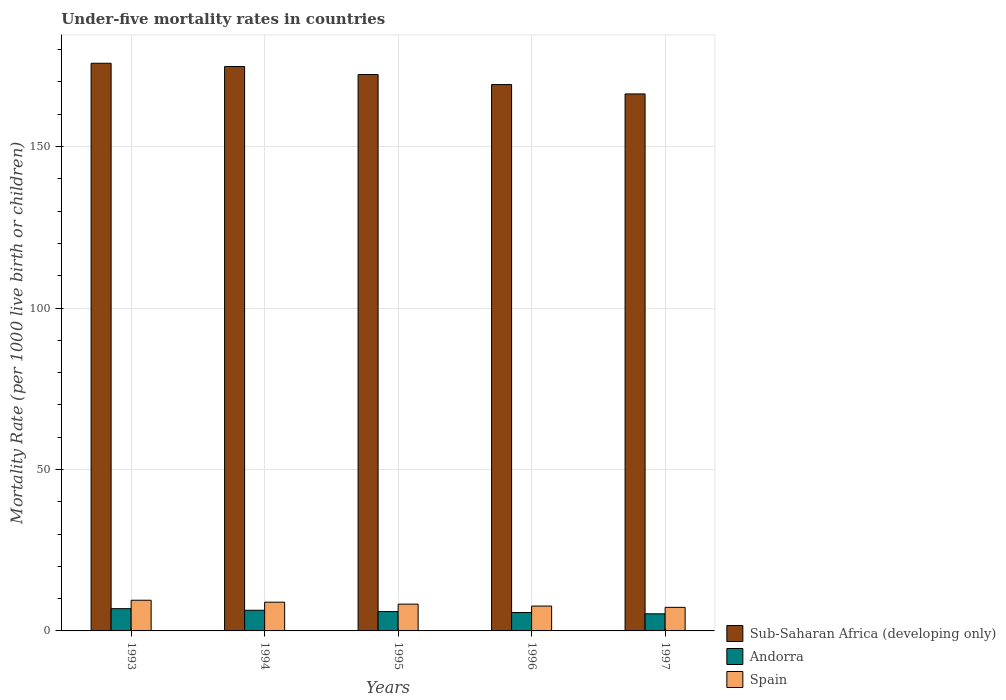How many bars are there on the 3rd tick from the left?
Offer a terse response. 3. What is the label of the 5th group of bars from the left?
Your answer should be very brief. 1997. In how many cases, is the number of bars for a given year not equal to the number of legend labels?
Keep it short and to the point. 0. Across all years, what is the maximum under-five mortality rate in Andorra?
Offer a very short reply. 6.9. In which year was the under-five mortality rate in Sub-Saharan Africa (developing only) minimum?
Offer a terse response. 1997. What is the total under-five mortality rate in Sub-Saharan Africa (developing only) in the graph?
Provide a short and direct response. 858.4. What is the difference between the under-five mortality rate in Spain in 1994 and that in 1995?
Your answer should be very brief. 0.6. What is the difference between the under-five mortality rate in Andorra in 1993 and the under-five mortality rate in Sub-Saharan Africa (developing only) in 1997?
Provide a succinct answer. -159.4. What is the average under-five mortality rate in Sub-Saharan Africa (developing only) per year?
Offer a very short reply. 171.68. What is the ratio of the under-five mortality rate in Sub-Saharan Africa (developing only) in 1995 to that in 1996?
Offer a terse response. 1.02. Is the difference between the under-five mortality rate in Andorra in 1993 and 1997 greater than the difference between the under-five mortality rate in Spain in 1993 and 1997?
Keep it short and to the point. No. What is the difference between the highest and the second highest under-five mortality rate in Sub-Saharan Africa (developing only)?
Give a very brief answer. 1. In how many years, is the under-five mortality rate in Sub-Saharan Africa (developing only) greater than the average under-five mortality rate in Sub-Saharan Africa (developing only) taken over all years?
Your response must be concise. 3. Is it the case that in every year, the sum of the under-five mortality rate in Sub-Saharan Africa (developing only) and under-five mortality rate in Spain is greater than the under-five mortality rate in Andorra?
Provide a succinct answer. Yes. How many bars are there?
Give a very brief answer. 15. Where does the legend appear in the graph?
Provide a succinct answer. Bottom right. How are the legend labels stacked?
Your response must be concise. Vertical. What is the title of the graph?
Your answer should be very brief. Under-five mortality rates in countries. Does "Cabo Verde" appear as one of the legend labels in the graph?
Your answer should be compact. No. What is the label or title of the Y-axis?
Provide a short and direct response. Mortality Rate (per 1000 live birth or children). What is the Mortality Rate (per 1000 live birth or children) in Sub-Saharan Africa (developing only) in 1993?
Ensure brevity in your answer.  175.8. What is the Mortality Rate (per 1000 live birth or children) of Andorra in 1993?
Provide a succinct answer. 6.9. What is the Mortality Rate (per 1000 live birth or children) in Sub-Saharan Africa (developing only) in 1994?
Offer a terse response. 174.8. What is the Mortality Rate (per 1000 live birth or children) of Spain in 1994?
Offer a terse response. 8.9. What is the Mortality Rate (per 1000 live birth or children) of Sub-Saharan Africa (developing only) in 1995?
Your answer should be compact. 172.3. What is the Mortality Rate (per 1000 live birth or children) in Spain in 1995?
Make the answer very short. 8.3. What is the Mortality Rate (per 1000 live birth or children) in Sub-Saharan Africa (developing only) in 1996?
Offer a terse response. 169.2. What is the Mortality Rate (per 1000 live birth or children) of Sub-Saharan Africa (developing only) in 1997?
Offer a very short reply. 166.3. What is the Mortality Rate (per 1000 live birth or children) in Spain in 1997?
Make the answer very short. 7.3. Across all years, what is the maximum Mortality Rate (per 1000 live birth or children) in Sub-Saharan Africa (developing only)?
Your answer should be compact. 175.8. Across all years, what is the minimum Mortality Rate (per 1000 live birth or children) of Sub-Saharan Africa (developing only)?
Offer a terse response. 166.3. Across all years, what is the minimum Mortality Rate (per 1000 live birth or children) of Spain?
Ensure brevity in your answer.  7.3. What is the total Mortality Rate (per 1000 live birth or children) of Sub-Saharan Africa (developing only) in the graph?
Make the answer very short. 858.4. What is the total Mortality Rate (per 1000 live birth or children) of Andorra in the graph?
Ensure brevity in your answer.  30.3. What is the total Mortality Rate (per 1000 live birth or children) in Spain in the graph?
Give a very brief answer. 41.7. What is the difference between the Mortality Rate (per 1000 live birth or children) in Andorra in 1993 and that in 1994?
Offer a terse response. 0.5. What is the difference between the Mortality Rate (per 1000 live birth or children) of Spain in 1993 and that in 1994?
Ensure brevity in your answer.  0.6. What is the difference between the Mortality Rate (per 1000 live birth or children) in Sub-Saharan Africa (developing only) in 1993 and that in 1995?
Give a very brief answer. 3.5. What is the difference between the Mortality Rate (per 1000 live birth or children) in Andorra in 1993 and that in 1995?
Make the answer very short. 0.9. What is the difference between the Mortality Rate (per 1000 live birth or children) of Spain in 1993 and that in 1995?
Your response must be concise. 1.2. What is the difference between the Mortality Rate (per 1000 live birth or children) in Sub-Saharan Africa (developing only) in 1993 and that in 1996?
Make the answer very short. 6.6. What is the difference between the Mortality Rate (per 1000 live birth or children) in Spain in 1993 and that in 1996?
Your response must be concise. 1.8. What is the difference between the Mortality Rate (per 1000 live birth or children) of Spain in 1993 and that in 1997?
Make the answer very short. 2.2. What is the difference between the Mortality Rate (per 1000 live birth or children) of Sub-Saharan Africa (developing only) in 1994 and that in 1995?
Make the answer very short. 2.5. What is the difference between the Mortality Rate (per 1000 live birth or children) of Spain in 1994 and that in 1995?
Make the answer very short. 0.6. What is the difference between the Mortality Rate (per 1000 live birth or children) of Andorra in 1994 and that in 1997?
Your response must be concise. 1.1. What is the difference between the Mortality Rate (per 1000 live birth or children) of Sub-Saharan Africa (developing only) in 1995 and that in 1996?
Offer a very short reply. 3.1. What is the difference between the Mortality Rate (per 1000 live birth or children) in Andorra in 1995 and that in 1996?
Offer a terse response. 0.3. What is the difference between the Mortality Rate (per 1000 live birth or children) of Andorra in 1995 and that in 1997?
Provide a short and direct response. 0.7. What is the difference between the Mortality Rate (per 1000 live birth or children) in Sub-Saharan Africa (developing only) in 1996 and that in 1997?
Keep it short and to the point. 2.9. What is the difference between the Mortality Rate (per 1000 live birth or children) of Andorra in 1996 and that in 1997?
Your answer should be very brief. 0.4. What is the difference between the Mortality Rate (per 1000 live birth or children) in Spain in 1996 and that in 1997?
Your answer should be compact. 0.4. What is the difference between the Mortality Rate (per 1000 live birth or children) in Sub-Saharan Africa (developing only) in 1993 and the Mortality Rate (per 1000 live birth or children) in Andorra in 1994?
Keep it short and to the point. 169.4. What is the difference between the Mortality Rate (per 1000 live birth or children) of Sub-Saharan Africa (developing only) in 1993 and the Mortality Rate (per 1000 live birth or children) of Spain in 1994?
Provide a succinct answer. 166.9. What is the difference between the Mortality Rate (per 1000 live birth or children) in Andorra in 1993 and the Mortality Rate (per 1000 live birth or children) in Spain in 1994?
Ensure brevity in your answer.  -2. What is the difference between the Mortality Rate (per 1000 live birth or children) in Sub-Saharan Africa (developing only) in 1993 and the Mortality Rate (per 1000 live birth or children) in Andorra in 1995?
Make the answer very short. 169.8. What is the difference between the Mortality Rate (per 1000 live birth or children) of Sub-Saharan Africa (developing only) in 1993 and the Mortality Rate (per 1000 live birth or children) of Spain in 1995?
Offer a very short reply. 167.5. What is the difference between the Mortality Rate (per 1000 live birth or children) in Andorra in 1993 and the Mortality Rate (per 1000 live birth or children) in Spain in 1995?
Offer a very short reply. -1.4. What is the difference between the Mortality Rate (per 1000 live birth or children) in Sub-Saharan Africa (developing only) in 1993 and the Mortality Rate (per 1000 live birth or children) in Andorra in 1996?
Keep it short and to the point. 170.1. What is the difference between the Mortality Rate (per 1000 live birth or children) of Sub-Saharan Africa (developing only) in 1993 and the Mortality Rate (per 1000 live birth or children) of Spain in 1996?
Offer a terse response. 168.1. What is the difference between the Mortality Rate (per 1000 live birth or children) of Sub-Saharan Africa (developing only) in 1993 and the Mortality Rate (per 1000 live birth or children) of Andorra in 1997?
Give a very brief answer. 170.5. What is the difference between the Mortality Rate (per 1000 live birth or children) in Sub-Saharan Africa (developing only) in 1993 and the Mortality Rate (per 1000 live birth or children) in Spain in 1997?
Your answer should be very brief. 168.5. What is the difference between the Mortality Rate (per 1000 live birth or children) in Sub-Saharan Africa (developing only) in 1994 and the Mortality Rate (per 1000 live birth or children) in Andorra in 1995?
Your response must be concise. 168.8. What is the difference between the Mortality Rate (per 1000 live birth or children) in Sub-Saharan Africa (developing only) in 1994 and the Mortality Rate (per 1000 live birth or children) in Spain in 1995?
Ensure brevity in your answer.  166.5. What is the difference between the Mortality Rate (per 1000 live birth or children) in Andorra in 1994 and the Mortality Rate (per 1000 live birth or children) in Spain in 1995?
Make the answer very short. -1.9. What is the difference between the Mortality Rate (per 1000 live birth or children) of Sub-Saharan Africa (developing only) in 1994 and the Mortality Rate (per 1000 live birth or children) of Andorra in 1996?
Give a very brief answer. 169.1. What is the difference between the Mortality Rate (per 1000 live birth or children) of Sub-Saharan Africa (developing only) in 1994 and the Mortality Rate (per 1000 live birth or children) of Spain in 1996?
Make the answer very short. 167.1. What is the difference between the Mortality Rate (per 1000 live birth or children) of Sub-Saharan Africa (developing only) in 1994 and the Mortality Rate (per 1000 live birth or children) of Andorra in 1997?
Provide a succinct answer. 169.5. What is the difference between the Mortality Rate (per 1000 live birth or children) in Sub-Saharan Africa (developing only) in 1994 and the Mortality Rate (per 1000 live birth or children) in Spain in 1997?
Your answer should be compact. 167.5. What is the difference between the Mortality Rate (per 1000 live birth or children) in Sub-Saharan Africa (developing only) in 1995 and the Mortality Rate (per 1000 live birth or children) in Andorra in 1996?
Offer a very short reply. 166.6. What is the difference between the Mortality Rate (per 1000 live birth or children) of Sub-Saharan Africa (developing only) in 1995 and the Mortality Rate (per 1000 live birth or children) of Spain in 1996?
Provide a short and direct response. 164.6. What is the difference between the Mortality Rate (per 1000 live birth or children) of Sub-Saharan Africa (developing only) in 1995 and the Mortality Rate (per 1000 live birth or children) of Andorra in 1997?
Keep it short and to the point. 167. What is the difference between the Mortality Rate (per 1000 live birth or children) of Sub-Saharan Africa (developing only) in 1995 and the Mortality Rate (per 1000 live birth or children) of Spain in 1997?
Make the answer very short. 165. What is the difference between the Mortality Rate (per 1000 live birth or children) in Sub-Saharan Africa (developing only) in 1996 and the Mortality Rate (per 1000 live birth or children) in Andorra in 1997?
Offer a very short reply. 163.9. What is the difference between the Mortality Rate (per 1000 live birth or children) in Sub-Saharan Africa (developing only) in 1996 and the Mortality Rate (per 1000 live birth or children) in Spain in 1997?
Provide a succinct answer. 161.9. What is the average Mortality Rate (per 1000 live birth or children) of Sub-Saharan Africa (developing only) per year?
Provide a short and direct response. 171.68. What is the average Mortality Rate (per 1000 live birth or children) in Andorra per year?
Keep it short and to the point. 6.06. What is the average Mortality Rate (per 1000 live birth or children) of Spain per year?
Offer a very short reply. 8.34. In the year 1993, what is the difference between the Mortality Rate (per 1000 live birth or children) of Sub-Saharan Africa (developing only) and Mortality Rate (per 1000 live birth or children) of Andorra?
Your response must be concise. 168.9. In the year 1993, what is the difference between the Mortality Rate (per 1000 live birth or children) in Sub-Saharan Africa (developing only) and Mortality Rate (per 1000 live birth or children) in Spain?
Offer a very short reply. 166.3. In the year 1994, what is the difference between the Mortality Rate (per 1000 live birth or children) in Sub-Saharan Africa (developing only) and Mortality Rate (per 1000 live birth or children) in Andorra?
Provide a short and direct response. 168.4. In the year 1994, what is the difference between the Mortality Rate (per 1000 live birth or children) of Sub-Saharan Africa (developing only) and Mortality Rate (per 1000 live birth or children) of Spain?
Offer a very short reply. 165.9. In the year 1995, what is the difference between the Mortality Rate (per 1000 live birth or children) in Sub-Saharan Africa (developing only) and Mortality Rate (per 1000 live birth or children) in Andorra?
Your response must be concise. 166.3. In the year 1995, what is the difference between the Mortality Rate (per 1000 live birth or children) of Sub-Saharan Africa (developing only) and Mortality Rate (per 1000 live birth or children) of Spain?
Your answer should be very brief. 164. In the year 1995, what is the difference between the Mortality Rate (per 1000 live birth or children) in Andorra and Mortality Rate (per 1000 live birth or children) in Spain?
Your answer should be compact. -2.3. In the year 1996, what is the difference between the Mortality Rate (per 1000 live birth or children) in Sub-Saharan Africa (developing only) and Mortality Rate (per 1000 live birth or children) in Andorra?
Your answer should be compact. 163.5. In the year 1996, what is the difference between the Mortality Rate (per 1000 live birth or children) of Sub-Saharan Africa (developing only) and Mortality Rate (per 1000 live birth or children) of Spain?
Ensure brevity in your answer.  161.5. In the year 1996, what is the difference between the Mortality Rate (per 1000 live birth or children) in Andorra and Mortality Rate (per 1000 live birth or children) in Spain?
Ensure brevity in your answer.  -2. In the year 1997, what is the difference between the Mortality Rate (per 1000 live birth or children) in Sub-Saharan Africa (developing only) and Mortality Rate (per 1000 live birth or children) in Andorra?
Offer a terse response. 161. In the year 1997, what is the difference between the Mortality Rate (per 1000 live birth or children) in Sub-Saharan Africa (developing only) and Mortality Rate (per 1000 live birth or children) in Spain?
Provide a succinct answer. 159. In the year 1997, what is the difference between the Mortality Rate (per 1000 live birth or children) of Andorra and Mortality Rate (per 1000 live birth or children) of Spain?
Your answer should be compact. -2. What is the ratio of the Mortality Rate (per 1000 live birth or children) of Sub-Saharan Africa (developing only) in 1993 to that in 1994?
Give a very brief answer. 1.01. What is the ratio of the Mortality Rate (per 1000 live birth or children) of Andorra in 1993 to that in 1994?
Offer a terse response. 1.08. What is the ratio of the Mortality Rate (per 1000 live birth or children) of Spain in 1993 to that in 1994?
Offer a terse response. 1.07. What is the ratio of the Mortality Rate (per 1000 live birth or children) in Sub-Saharan Africa (developing only) in 1993 to that in 1995?
Make the answer very short. 1.02. What is the ratio of the Mortality Rate (per 1000 live birth or children) of Andorra in 1993 to that in 1995?
Make the answer very short. 1.15. What is the ratio of the Mortality Rate (per 1000 live birth or children) in Spain in 1993 to that in 1995?
Your answer should be compact. 1.14. What is the ratio of the Mortality Rate (per 1000 live birth or children) of Sub-Saharan Africa (developing only) in 1993 to that in 1996?
Provide a succinct answer. 1.04. What is the ratio of the Mortality Rate (per 1000 live birth or children) of Andorra in 1993 to that in 1996?
Provide a short and direct response. 1.21. What is the ratio of the Mortality Rate (per 1000 live birth or children) in Spain in 1993 to that in 1996?
Your response must be concise. 1.23. What is the ratio of the Mortality Rate (per 1000 live birth or children) of Sub-Saharan Africa (developing only) in 1993 to that in 1997?
Your answer should be very brief. 1.06. What is the ratio of the Mortality Rate (per 1000 live birth or children) of Andorra in 1993 to that in 1997?
Your answer should be compact. 1.3. What is the ratio of the Mortality Rate (per 1000 live birth or children) in Spain in 1993 to that in 1997?
Give a very brief answer. 1.3. What is the ratio of the Mortality Rate (per 1000 live birth or children) of Sub-Saharan Africa (developing only) in 1994 to that in 1995?
Make the answer very short. 1.01. What is the ratio of the Mortality Rate (per 1000 live birth or children) in Andorra in 1994 to that in 1995?
Your answer should be very brief. 1.07. What is the ratio of the Mortality Rate (per 1000 live birth or children) of Spain in 1994 to that in 1995?
Provide a succinct answer. 1.07. What is the ratio of the Mortality Rate (per 1000 live birth or children) of Sub-Saharan Africa (developing only) in 1994 to that in 1996?
Your answer should be very brief. 1.03. What is the ratio of the Mortality Rate (per 1000 live birth or children) in Andorra in 1994 to that in 1996?
Your answer should be compact. 1.12. What is the ratio of the Mortality Rate (per 1000 live birth or children) of Spain in 1994 to that in 1996?
Provide a succinct answer. 1.16. What is the ratio of the Mortality Rate (per 1000 live birth or children) of Sub-Saharan Africa (developing only) in 1994 to that in 1997?
Provide a short and direct response. 1.05. What is the ratio of the Mortality Rate (per 1000 live birth or children) of Andorra in 1994 to that in 1997?
Provide a short and direct response. 1.21. What is the ratio of the Mortality Rate (per 1000 live birth or children) of Spain in 1994 to that in 1997?
Your answer should be very brief. 1.22. What is the ratio of the Mortality Rate (per 1000 live birth or children) in Sub-Saharan Africa (developing only) in 1995 to that in 1996?
Offer a terse response. 1.02. What is the ratio of the Mortality Rate (per 1000 live birth or children) of Andorra in 1995 to that in 1996?
Give a very brief answer. 1.05. What is the ratio of the Mortality Rate (per 1000 live birth or children) in Spain in 1995 to that in 1996?
Offer a very short reply. 1.08. What is the ratio of the Mortality Rate (per 1000 live birth or children) in Sub-Saharan Africa (developing only) in 1995 to that in 1997?
Your answer should be compact. 1.04. What is the ratio of the Mortality Rate (per 1000 live birth or children) of Andorra in 1995 to that in 1997?
Provide a short and direct response. 1.13. What is the ratio of the Mortality Rate (per 1000 live birth or children) in Spain in 1995 to that in 1997?
Give a very brief answer. 1.14. What is the ratio of the Mortality Rate (per 1000 live birth or children) of Sub-Saharan Africa (developing only) in 1996 to that in 1997?
Provide a short and direct response. 1.02. What is the ratio of the Mortality Rate (per 1000 live birth or children) of Andorra in 1996 to that in 1997?
Offer a very short reply. 1.08. What is the ratio of the Mortality Rate (per 1000 live birth or children) in Spain in 1996 to that in 1997?
Ensure brevity in your answer.  1.05. What is the difference between the highest and the second highest Mortality Rate (per 1000 live birth or children) of Andorra?
Provide a short and direct response. 0.5. What is the difference between the highest and the lowest Mortality Rate (per 1000 live birth or children) of Sub-Saharan Africa (developing only)?
Provide a short and direct response. 9.5. What is the difference between the highest and the lowest Mortality Rate (per 1000 live birth or children) in Andorra?
Make the answer very short. 1.6. What is the difference between the highest and the lowest Mortality Rate (per 1000 live birth or children) in Spain?
Make the answer very short. 2.2. 